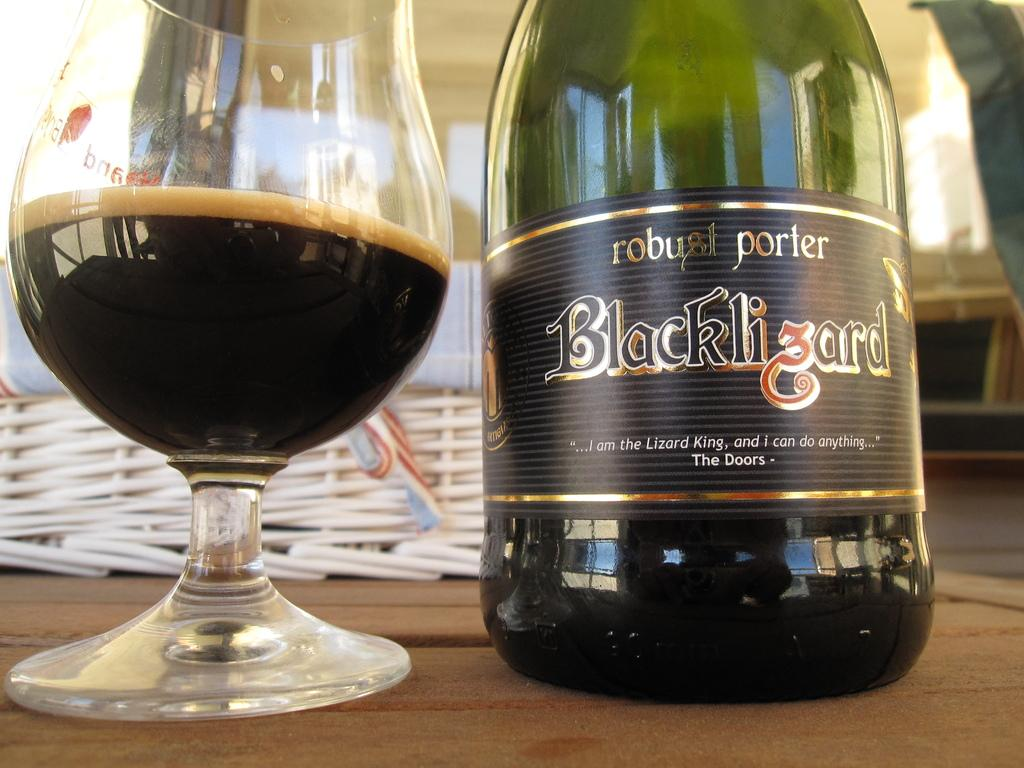What is present on the table in the image? There is a bottle and a glass with a drink in the image. What is the purpose of the bottle in the image? The purpose of the bottle is not explicitly stated, but it may contain a beverage or other liquid. What is the glass with a drink used for? The glass with a drink is likely used for consuming the beverage. What idea is being expressed on the note in the image? There is no note present in the image, so no idea can be expressed. Can you describe the swimming technique of the person in the image? There is no person swimming in the image; it only features a bottle and a glass with a drink on a table. 